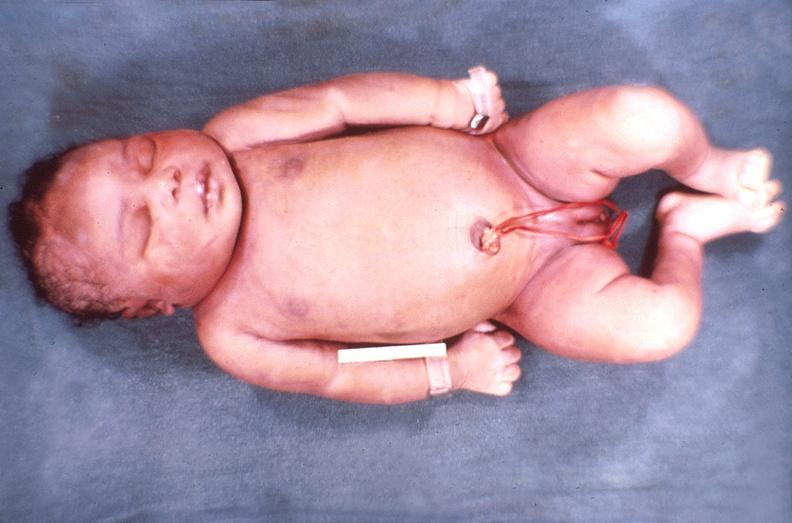what does this image show?
Answer the question using a single word or phrase. Hemolytic disease of newborn 